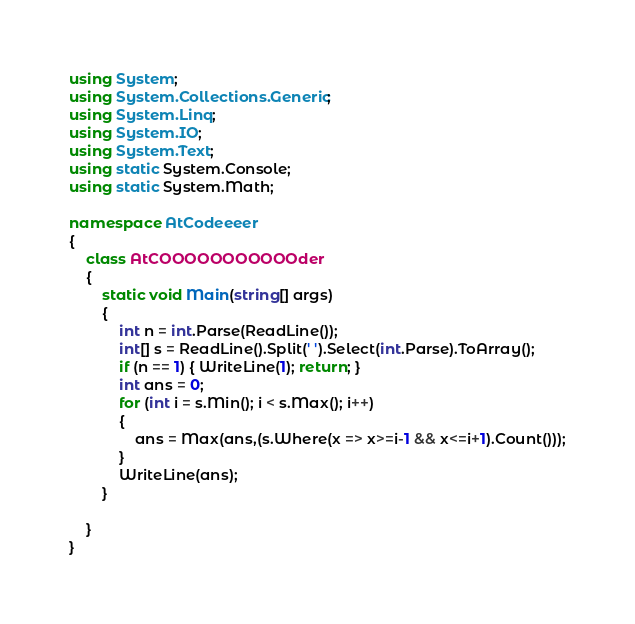<code> <loc_0><loc_0><loc_500><loc_500><_C#_>using System;
using System.Collections.Generic;
using System.Linq;
using System.IO;
using System.Text;
using static System.Console;
using static System.Math;

namespace AtCodeeeer
{
    class AtCOOOOOOOOOOOder
    {
        static void Main(string[] args)
        {
            int n = int.Parse(ReadLine());
            int[] s = ReadLine().Split(' ').Select(int.Parse).ToArray();
            if (n == 1) { WriteLine(1); return; }
            int ans = 0;
            for (int i = s.Min(); i < s.Max(); i++)
            {
                ans = Max(ans,(s.Where(x => x>=i-1 && x<=i+1).Count()));
            }
            WriteLine(ans);
        }
        
    }
}</code> 